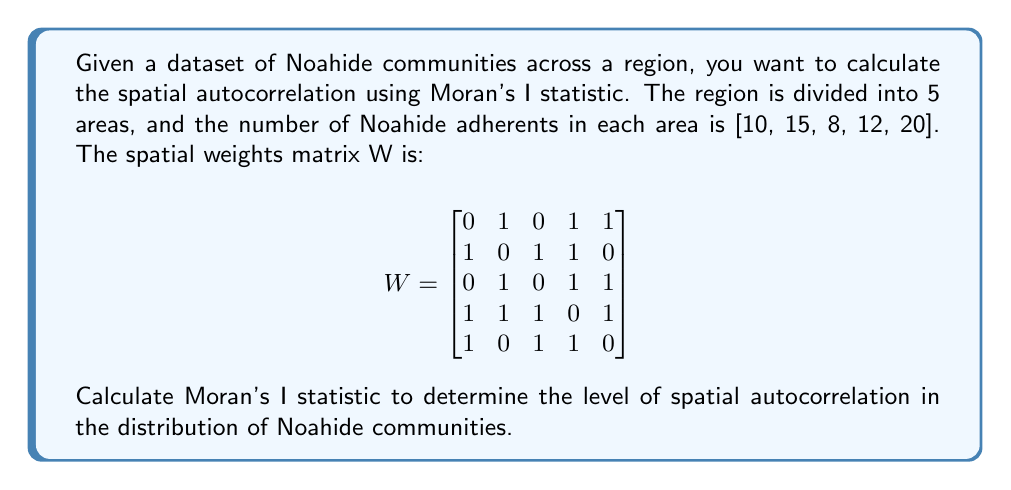Help me with this question. To calculate Moran's I statistic, we'll follow these steps:

1. Calculate the mean number of Noahide adherents:
   $\bar{x} = \frac{10 + 15 + 8 + 12 + 20}{5} = 13$

2. Calculate the deviations from the mean:
   $z_i = x_i - \bar{x}$
   $z = [10-13, 15-13, 8-13, 12-13, 20-13] = [-3, 2, -5, -1, 7]$

3. Calculate the sum of squared deviations:
   $\sum_{i=1}^n z_i^2 = (-3)^2 + 2^2 + (-5)^2 + (-1)^2 + 7^2 = 88$

4. Calculate the sum of spatial weights:
   $S_0 = \sum_{i=1}^n \sum_{j=1}^n w_{ij} = 20$ (sum of all elements in W)

5. Apply the Moran's I formula:
   $$I = \frac{n}{\sum_{i=1}^n \sum_{j=1}^n w_{ij}} \cdot \frac{\sum_{i=1}^n \sum_{j=1}^n w_{ij}(x_i - \bar{x})(x_j - \bar{x})}{\sum_{i=1}^n (x_i - \bar{x})^2}$$

   Where $n = 5$ (number of areas)

6. Calculate the numerator:
   $\sum_{i=1}^n \sum_{j=1}^n w_{ij}(x_i - \bar{x})(x_j - \bar{x})$
   $= (-3)(2 + -1 + 7) + 2(-3 + -1) + (-5)(-3 + -1 + 7) + (-1)(-3 + 2 + -5 + 7) + 7(-3 + -5 + -1)$
   $= (-3)(8) + 2(-4) + (-5)(3) + (-1)(1) + 7(-9)$
   $= -24 - 8 - 15 - 1 - 63 = -111$

7. Substitute into the formula:
   $$I = \frac{5}{20} \cdot \frac{-111}{88} = -0.3153409090909091$$

The Moran's I statistic ranges from -1 (perfect dispersion) to 1 (perfect correlation), with 0 indicating a random spatial pattern. Our result of approximately -0.3153 suggests a moderate level of negative spatial autocorrelation, meaning that Noahide communities in this region tend to be dispersed rather than clustered.
Answer: $-0.3153$ 